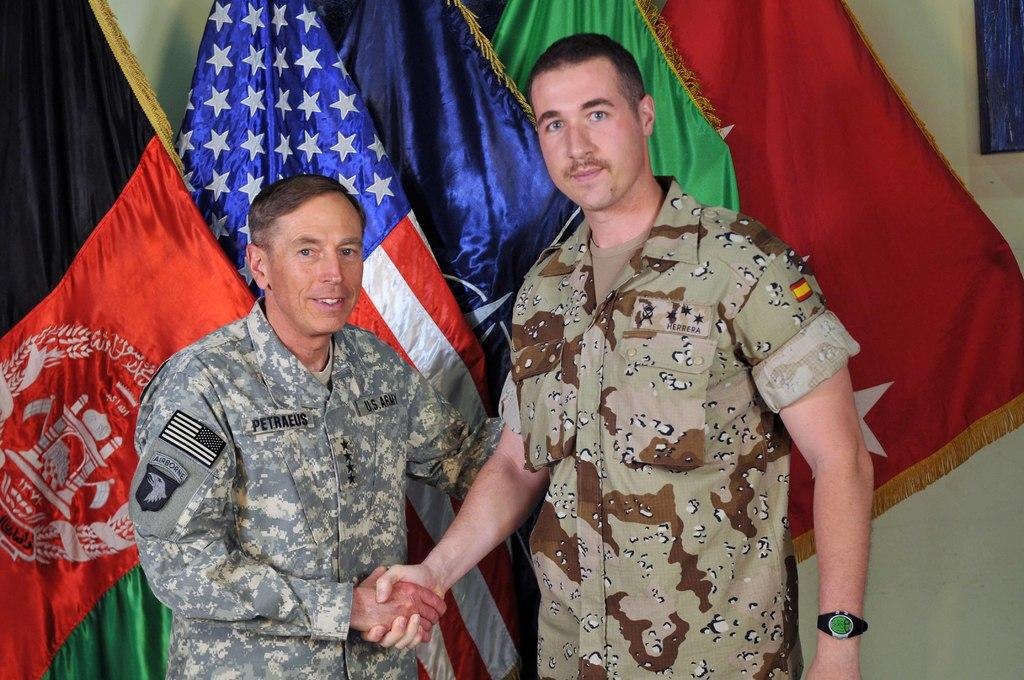Provide a one-sentence caption for the provided image. Petraeus shakes hands with a man who is taller than him. 